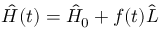Convert formula to latex. <formula><loc_0><loc_0><loc_500><loc_500>\hat { H } ( t ) = \hat { H } _ { 0 } + f ( t ) \hat { L }</formula> 